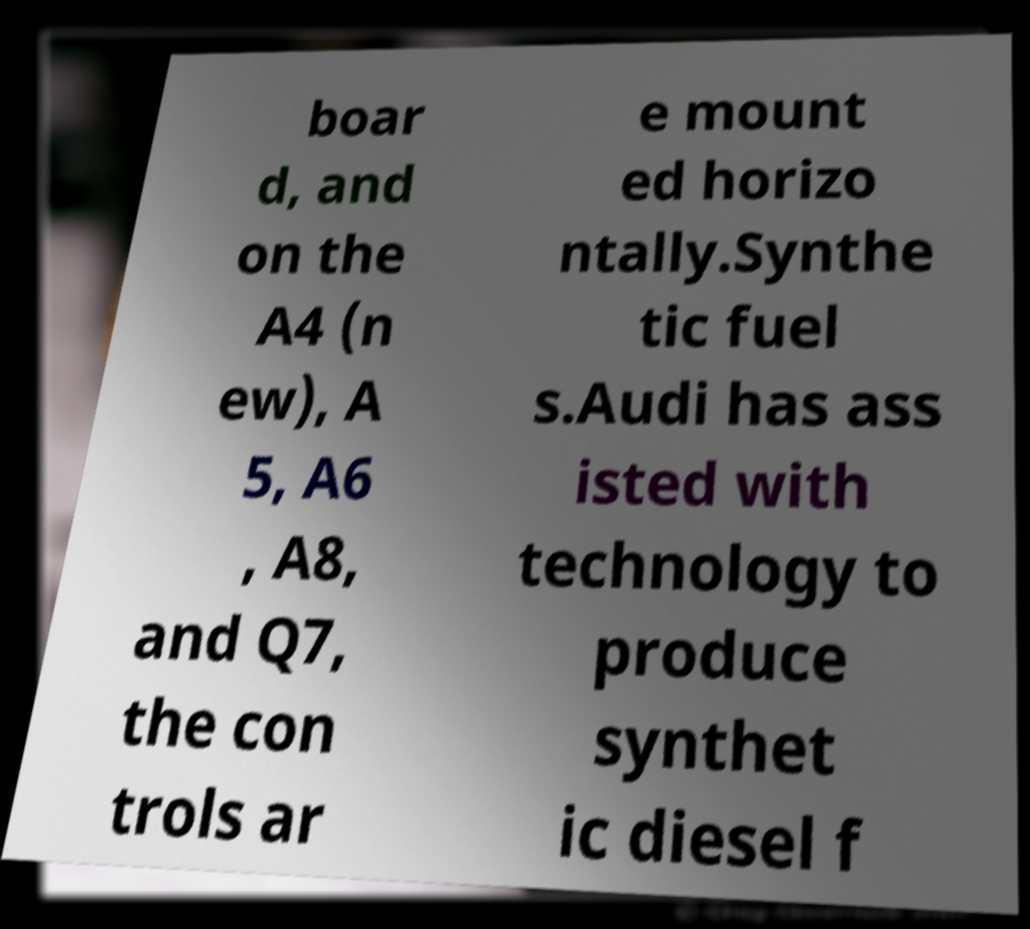There's text embedded in this image that I need extracted. Can you transcribe it verbatim? boar d, and on the A4 (n ew), A 5, A6 , A8, and Q7, the con trols ar e mount ed horizo ntally.Synthe tic fuel s.Audi has ass isted with technology to produce synthet ic diesel f 